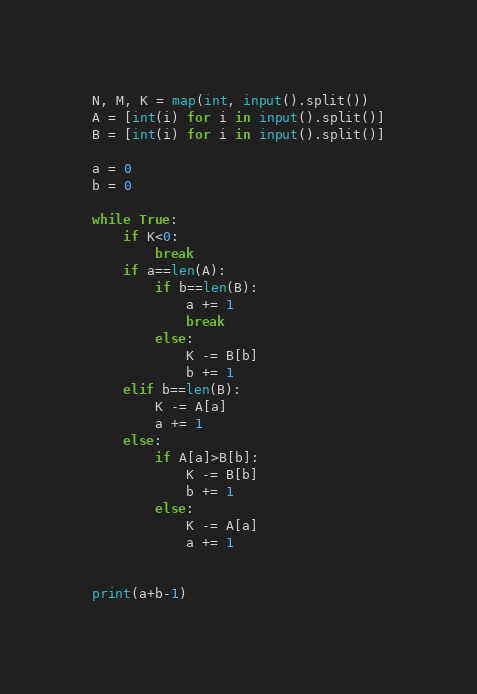Convert code to text. <code><loc_0><loc_0><loc_500><loc_500><_Python_>N, M, K = map(int, input().split())
A = [int(i) for i in input().split()]
B = [int(i) for i in input().split()]

a = 0
b = 0

while True:
    if K<0:
        break
    if a==len(A):
        if b==len(B):
            a += 1
            break
        else:
            K -= B[b]
            b += 1
    elif b==len(B):
        K -= A[a]
        a += 1
    else:
        if A[a]>B[b]:
            K -= B[b]
            b += 1
        else:
            K -= A[a]
            a += 1
    

print(a+b-1)</code> 